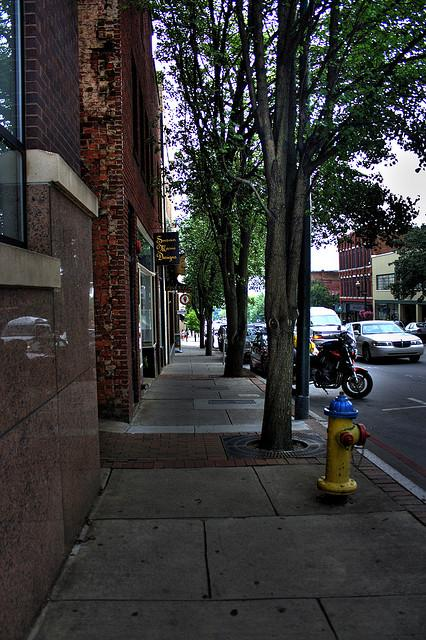What is the yellow object on the sidewalk connected to?

Choices:
A) wall
B) water lines
C) mayor
D) police water lines 